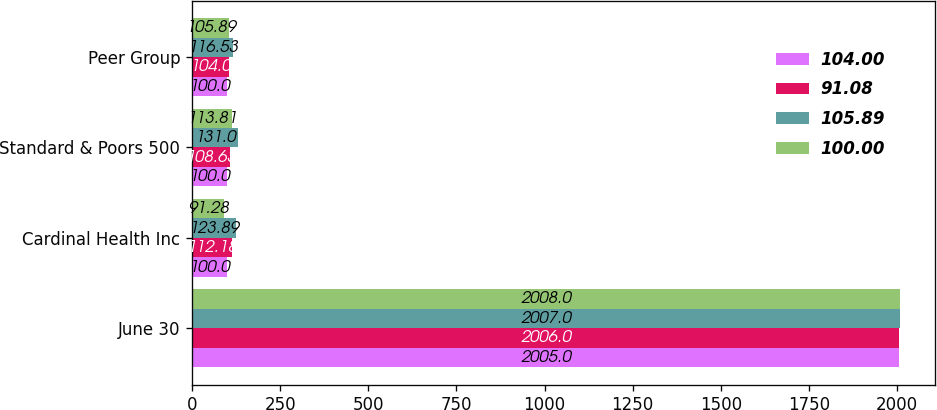<chart> <loc_0><loc_0><loc_500><loc_500><stacked_bar_chart><ecel><fcel>June 30<fcel>Cardinal Health Inc<fcel>Standard & Poors 500<fcel>Peer Group<nl><fcel>104<fcel>2005<fcel>100<fcel>100<fcel>100<nl><fcel>91.08<fcel>2006<fcel>112.18<fcel>108.63<fcel>104<nl><fcel>105.89<fcel>2007<fcel>123.89<fcel>131<fcel>116.53<nl><fcel>100<fcel>2008<fcel>91.28<fcel>113.81<fcel>105.89<nl></chart> 